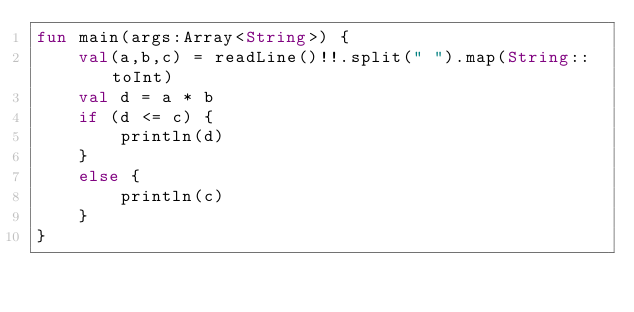Convert code to text. <code><loc_0><loc_0><loc_500><loc_500><_Kotlin_>fun main(args:Array<String>) {
    val(a,b,c) = readLine()!!.split(" ").map(String::toInt)
    val d = a * b
    if (d <= c) {
        println(d)
    }
    else {
        println(c)
    }
}
</code> 